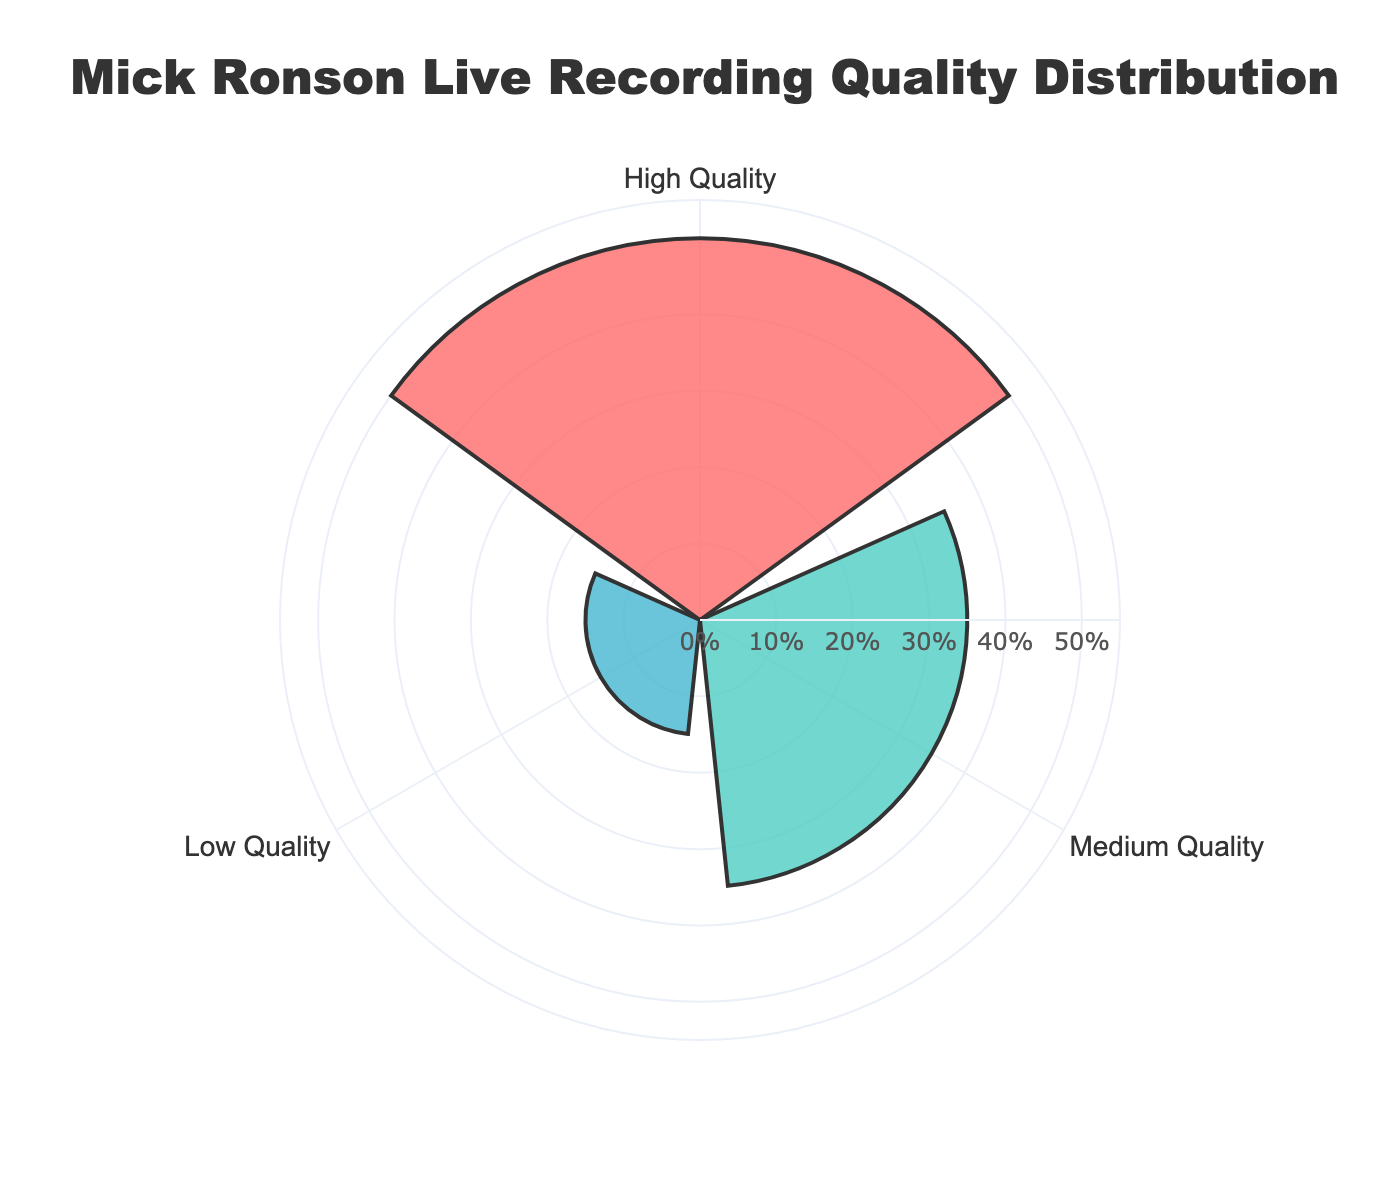What is the title of the chart? The title is displayed prominently at the top of the chart in a larger and bold font. It reads "Mick Ronson Live Recording Quality Distribution."
Answer: Mick Ronson Live Recording Quality Distribution How many quality categories are shown in the chart? There are three distinct colored areas in the rose chart, each representing a different quality category.
Answer: Three Which category has the highest percentage of live recordings? By observing the areas in the rose chart, the category with the largest extended section is "High Quality," indicated by its radial length.
Answer: High Quality How much more percentage of live recordings are in the 'High Quality' category compared to 'Low Quality'? The 'High Quality' section has a percentage of 50%, and the 'Low Quality' section has 15%. The difference is calculated as 50 - 15.
Answer: 35% What is the sum of percentages for the 'Medium Quality' and 'Low Quality' recordings? Add the percentages of 'Medium Quality' (35%) and 'Low Quality' (15%). The sum is 35 + 15.
Answer: 50% Is the percentage of 'Medium Quality' recordings greater than that of 'Low Quality' recordings? Compare the radial lengths of 'Medium Quality' (35%) and 'Low Quality' (15%) sections in the chart. The 'Medium Quality' section is greater.
Answer: Yes What percentage of live recordings are not 'High Quality'? To calculate the percentage of recordings that are not 'High Quality', sum the percentages of 'Medium Quality' and 'Low Quality', which are 35% and 15%, respectively. The calculation is 35 + 15.
Answer: 50% Which category has the smallest percentage in the distribution? The category with the smallest sector in the rose chart is 'Low Quality' with 15%.
Answer: Low Quality What's the average percentage of the three quality categories? Add the percentages of all categories and divide by the number of categories. (50% + 35% + 15%) / 3 = 100 / 3.
Answer: 33.33% What color is used to represent 'Medium Quality' recordings in the chart? The 'Medium Quality' category is represented by a distinct color in the chart, which is a greenish shade.
Answer: Greenish shade 